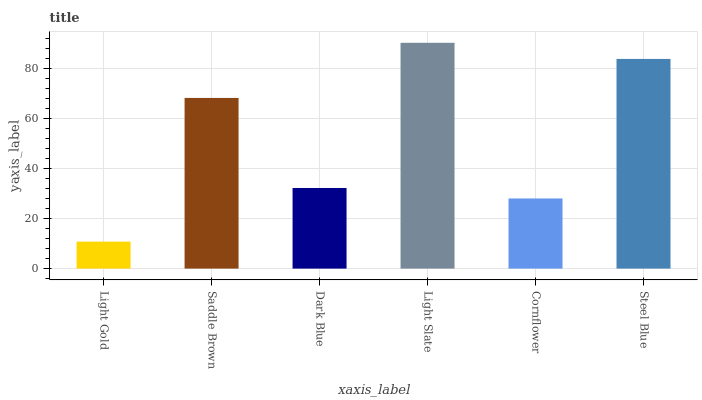Is Light Gold the minimum?
Answer yes or no. Yes. Is Light Slate the maximum?
Answer yes or no. Yes. Is Saddle Brown the minimum?
Answer yes or no. No. Is Saddle Brown the maximum?
Answer yes or no. No. Is Saddle Brown greater than Light Gold?
Answer yes or no. Yes. Is Light Gold less than Saddle Brown?
Answer yes or no. Yes. Is Light Gold greater than Saddle Brown?
Answer yes or no. No. Is Saddle Brown less than Light Gold?
Answer yes or no. No. Is Saddle Brown the high median?
Answer yes or no. Yes. Is Dark Blue the low median?
Answer yes or no. Yes. Is Light Gold the high median?
Answer yes or no. No. Is Steel Blue the low median?
Answer yes or no. No. 